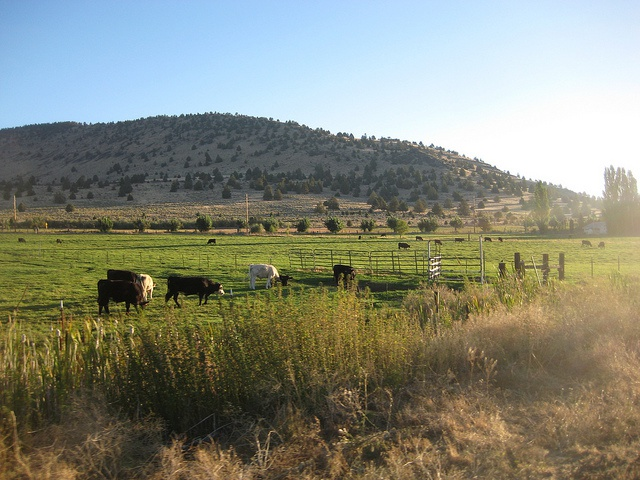Describe the objects in this image and their specific colors. I can see cow in darkgray, black, olive, maroon, and gray tones, cow in darkgray, black, darkgreen, and gray tones, cow in darkgray, gray, black, darkgreen, and khaki tones, cow in darkgray, black, darkgreen, and gray tones, and cow in darkgray, khaki, tan, and olive tones in this image. 